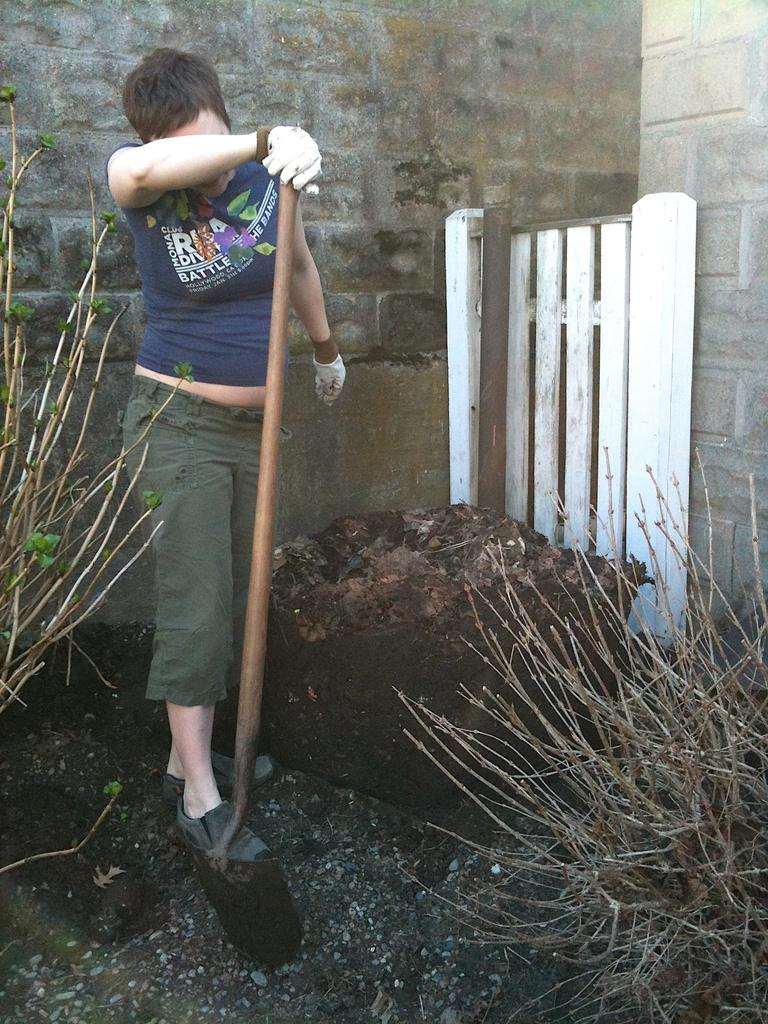Who is present in the image? There is a lady in the image. What is the lady holding in the image? The lady is holding a stick. What can be seen in the background of the image? There are plants, a rock, and a fence in the background of the image. What is visible at the bottom of the image? The ground is visible at the bottom of the image. How many apples can be seen on the lady's wing in the image? There are no apples or wings present in the image. 